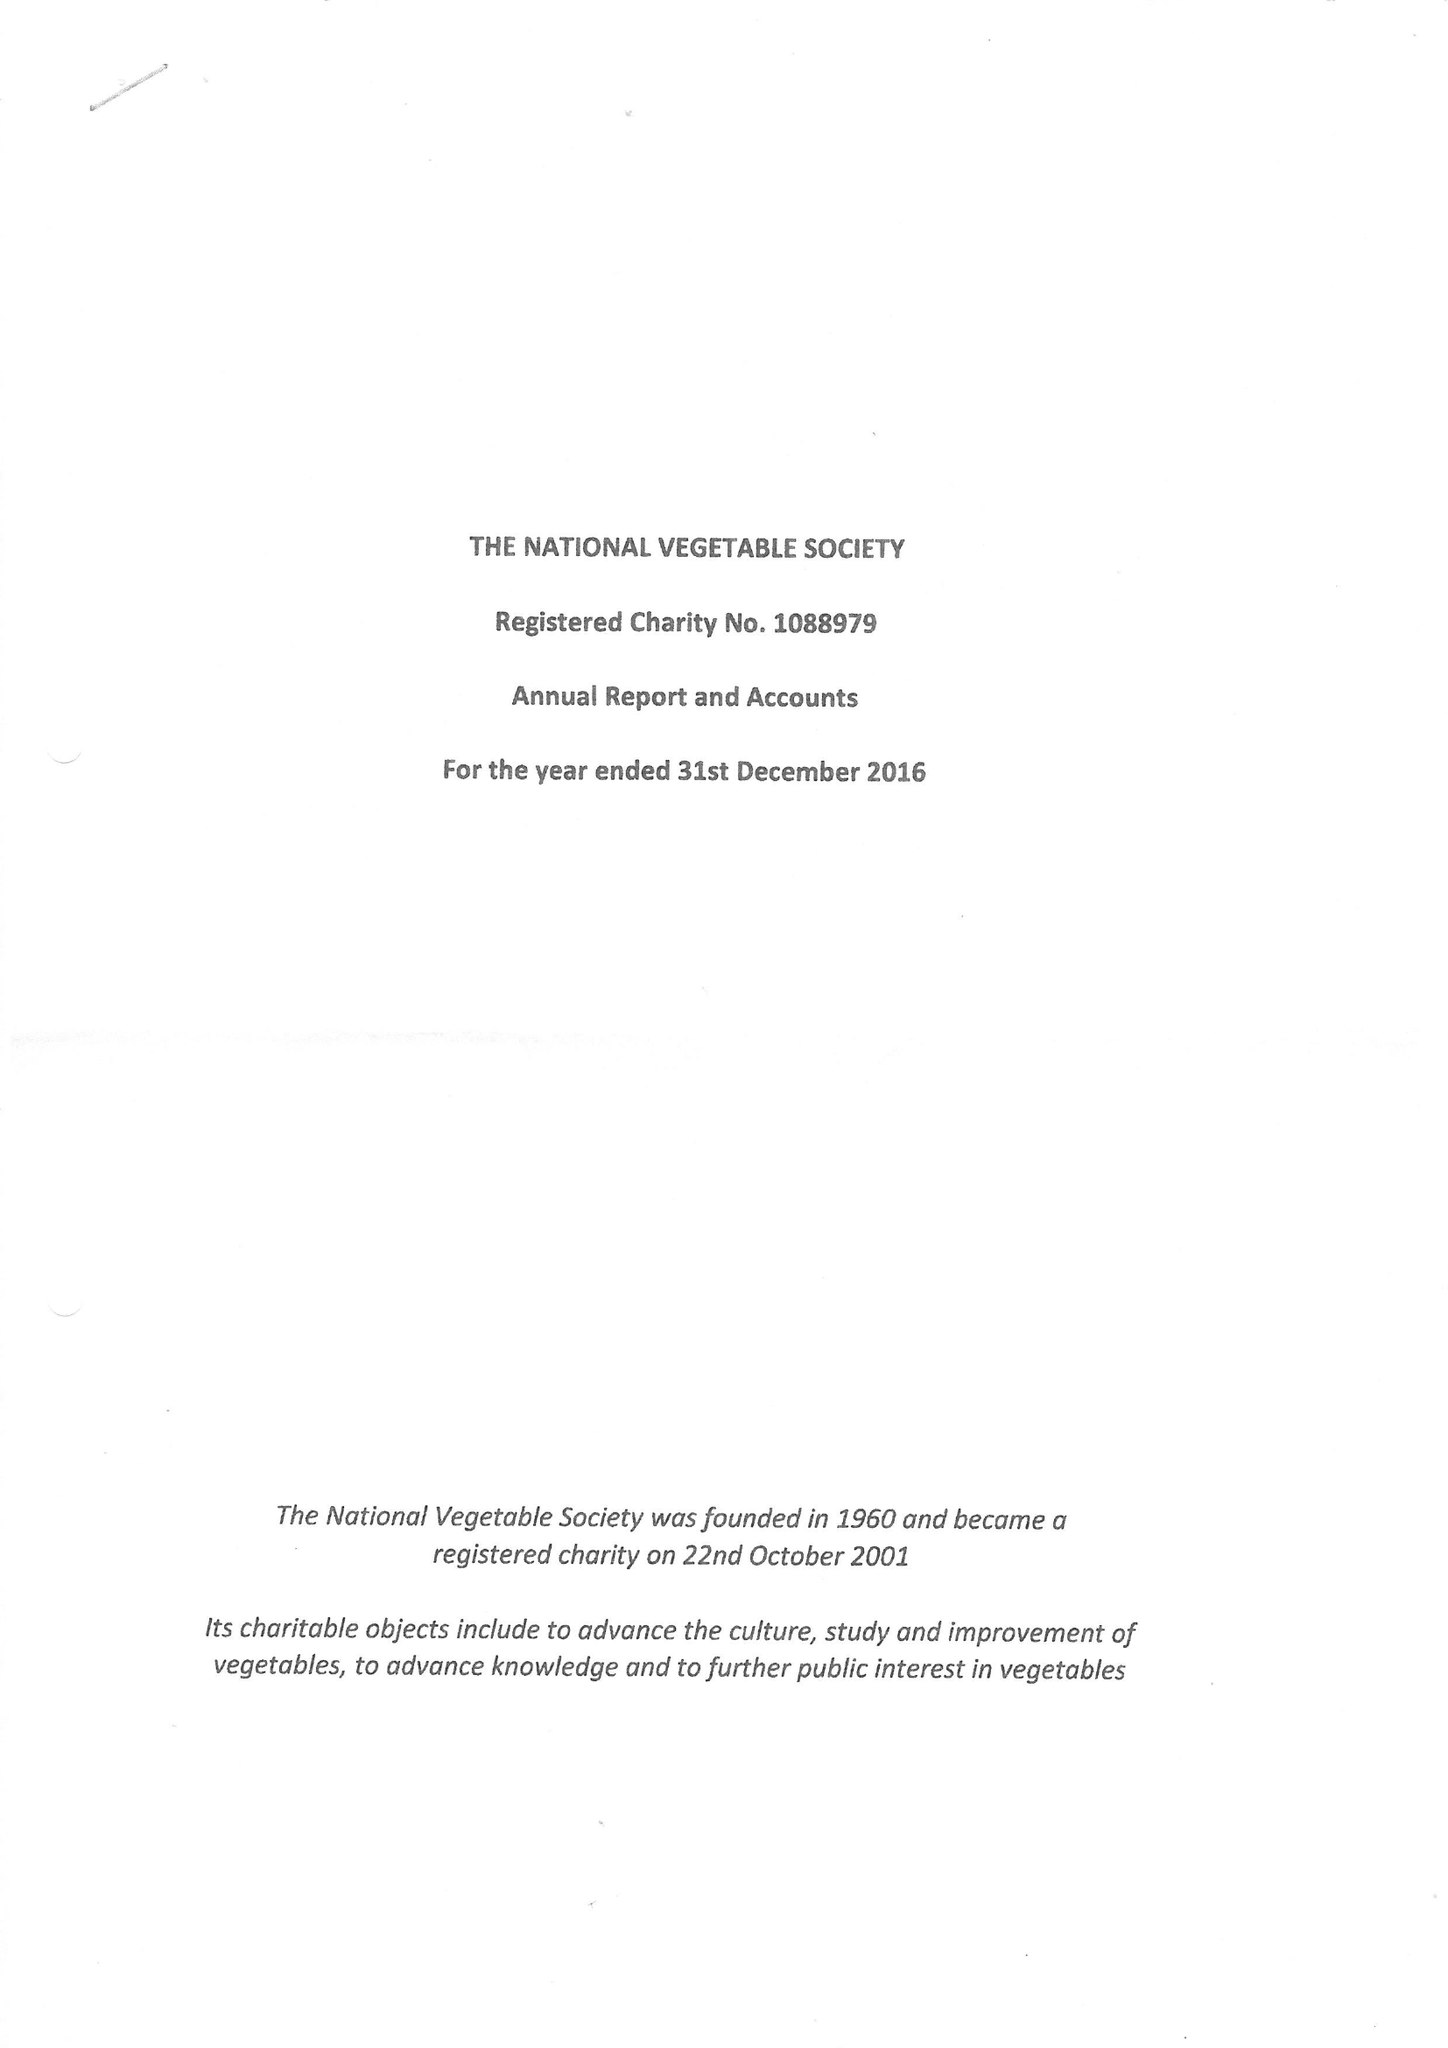What is the value for the income_annually_in_british_pounds?
Answer the question using a single word or phrase. 125241.00 